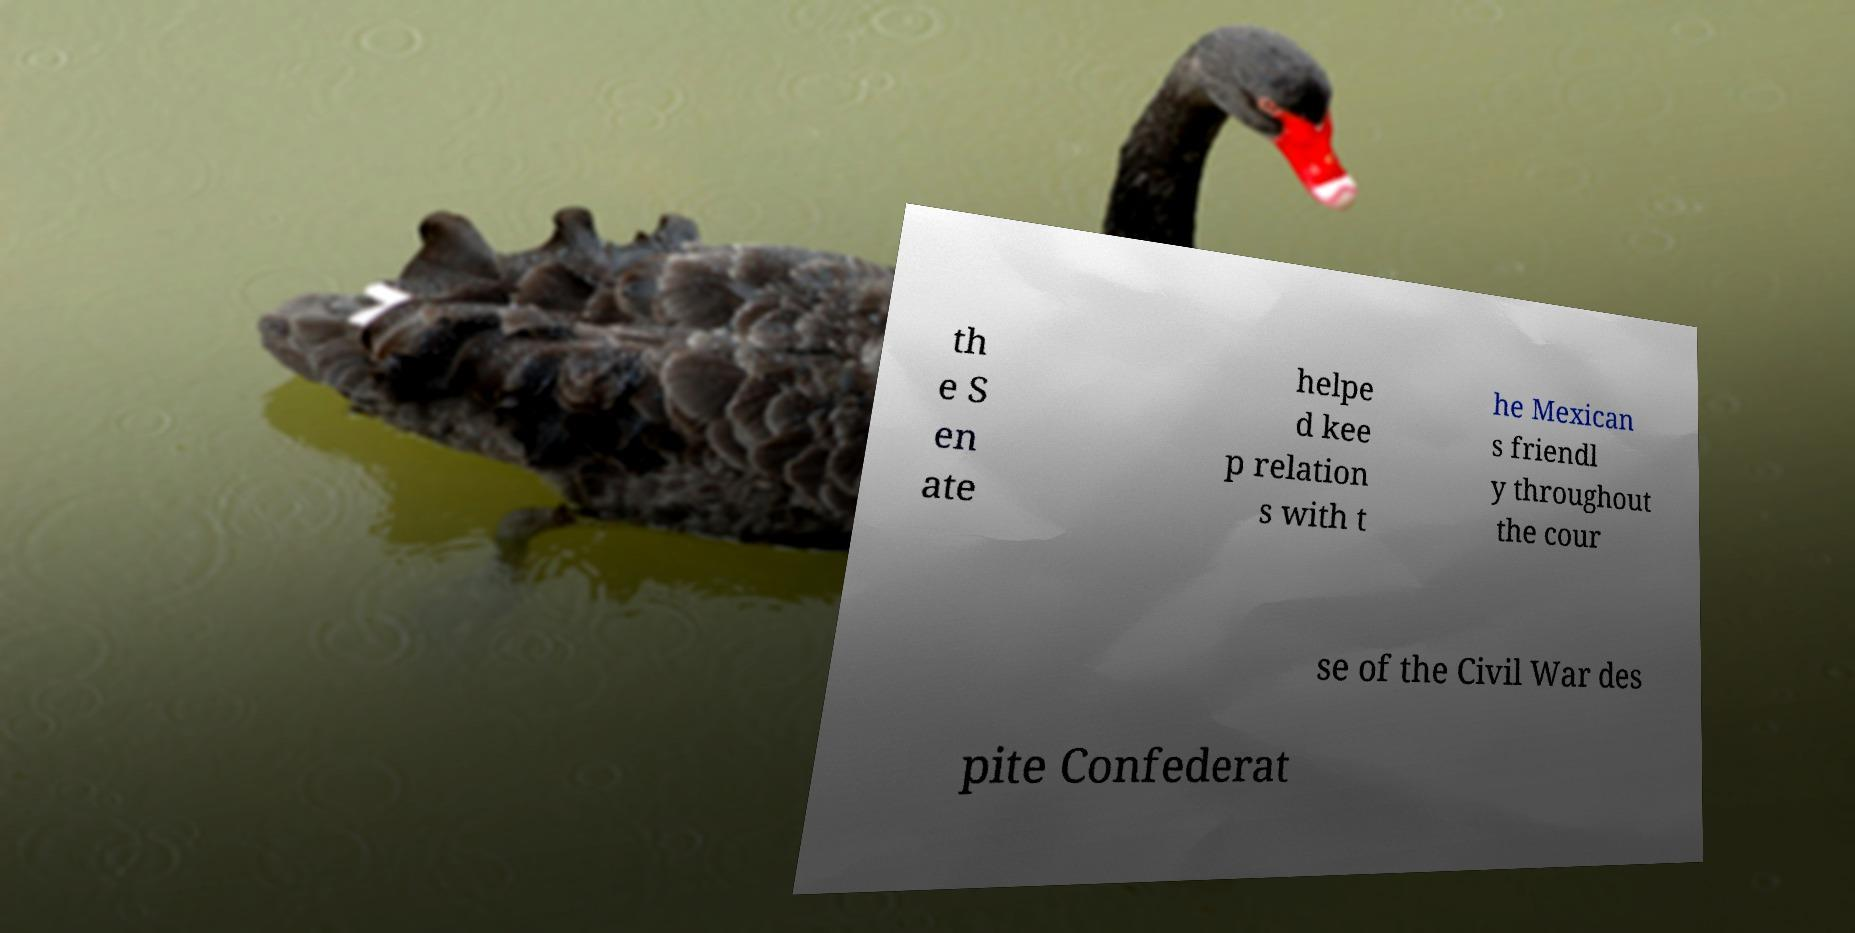Can you read and provide the text displayed in the image?This photo seems to have some interesting text. Can you extract and type it out for me? th e S en ate helpe d kee p relation s with t he Mexican s friendl y throughout the cour se of the Civil War des pite Confederat 